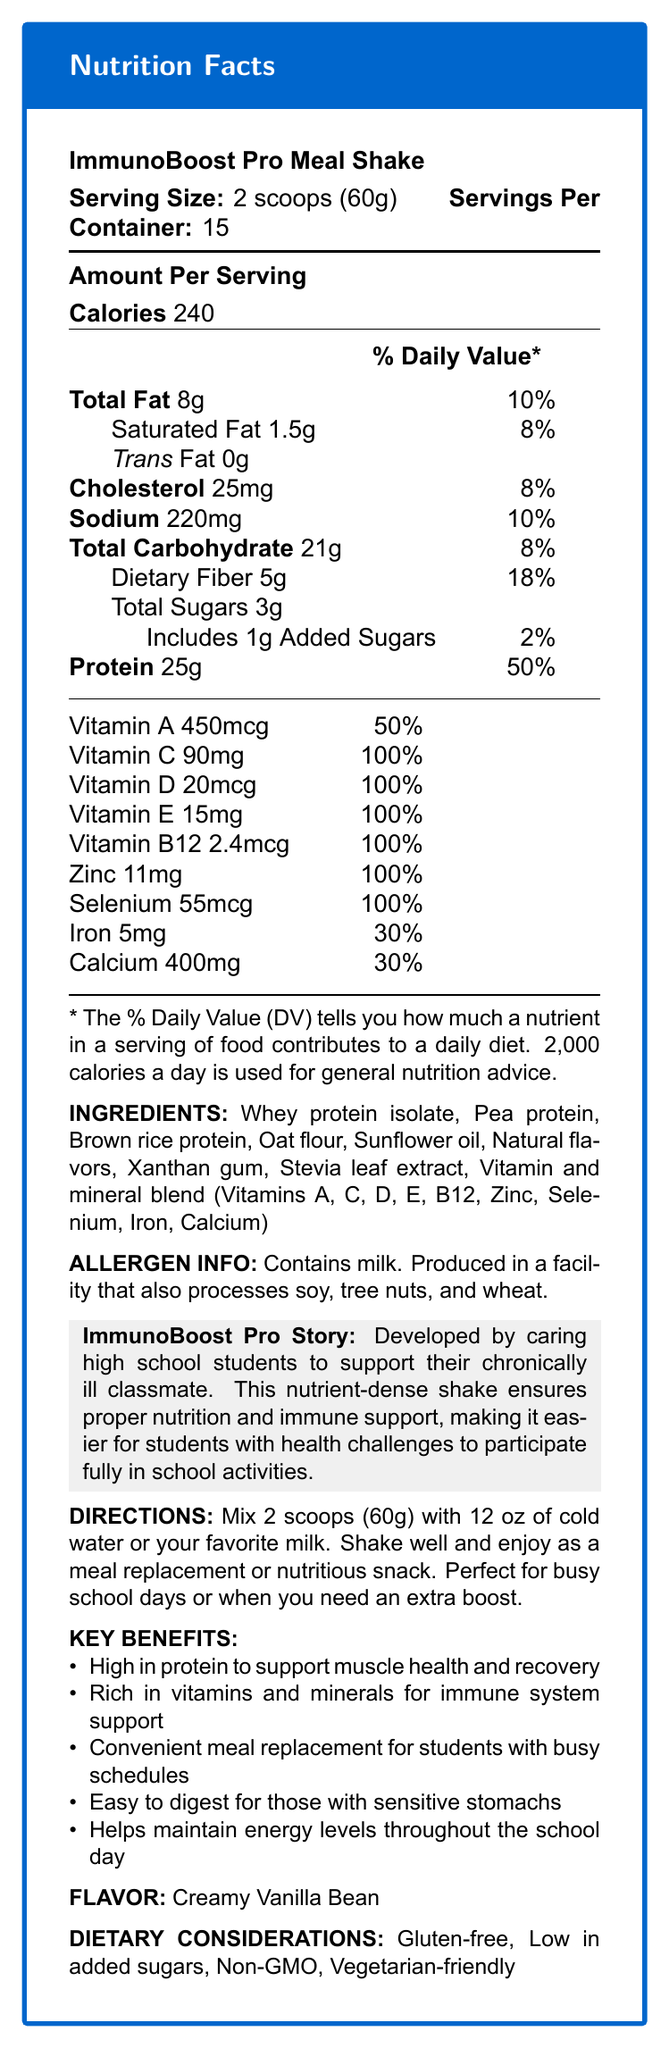What is the serving size for the ImmunoBoost Pro Meal Shake? The serving size is listed at the beginning of the document as "Serving Size: 2 scoops (60g)".
Answer: 2 scoops (60g) How many servings are there per container? The document specifies "Servings Per Container: 15".
Answer: 15 How many calories are there per serving of the shake? The "Amount Per Serving" section lists 240 calories.
Answer: 240 List three key benefits of the ImmunoBoost Pro Meal Shake. The key benefits section lists several benefits; these three are mentioned explicitly.
Answer: High in protein, Rich in vitamins and minerals for immune system support, Convenient meal replacement for busy schedules What is the amount of protein per serving? In the "Amount Per Serving" section, it mentions "Protein 25g".
Answer: 25g Does this product contain any allergens? The allergen information states "Contains milk. Produced in a facility that also processes soy, tree nuts, and wheat."
Answer: Yes What is the percentage daily value of vitamin C per serving? A. 50% B. 100% C. 25% D. 30% The document shows vitamin C has a daily value of 100%.
Answer: B. 100% Which vitamin is NOT included in the vitamin and mineral blend? A. Vitamin A B. Vitamin C C. Vitamin K D. Vitamin D The vitamin and mineral blend lists vitamins A, C, D, E, B12, zinc, selenium, iron, and calcium, but not vitamin K.
Answer: C. Vitamin K Is this meal replacement shake gluten-free? Under "Dietary Considerations," it states that the shake is gluten-free.
Answer: Yes Summarize the main purpose and benefits of the ImmunoBoost Pro Meal Shake. The document describes its development by caring students for a chronically ill classmate, highlighting its nutritional support and convenience.
Answer: The ImmunoBoost Pro Meal Shake is designed to support chronically ill students by providing a nutrient-dense, protein-rich meal replacement. It offers immune support through added vitamins and minerals, is easy to digest, and helps maintain energy levels throughout the school day. What is the natural flavoring agent used in this meal replacement shake? The ingredients list includes "Natural flavors" as one of the components.
Answer: Natural flavors What additional information would you need to determine if this product is suitable for someone with a peanut allergy? The document states it is produced in a facility that processes tree nuts but does not specify peanuts.
Answer: Not enough information When should you consume this meal replacement shake according to the directions? The directions mention these specific situations for consumption.
Answer: As a meal replacement or nutritious snack, perfect for busy school days or when you need an extra boost What flavor is the ImmunoBoost Pro Meal Shake? It is mentioned under "Flavor: Creamy Vanilla Bean".
Answer: Creamy Vanilla Bean How much fat is in each serving of the shake? A. 8g B. 1.5g C. 3g D. 0g The "Total Fat" is listed as 8g in the "Amount Per Serving" section.
Answer: A. 8g What is the role of the vitamins and minerals blend in the shake? One of the key benefits is "Rich in vitamins and minerals for immune system support".
Answer: To provide immune system support Can you determine the exact proportion of each protein source in the shake? The ingredients list includes whey protein isolate, pea protein, and brown rice protein but does not specify their proportions.
Answer: No, not enough information What is the daily value percentage for dietary fiber per serving? A. 30% B. 8% C. 10% D. 18% The "Dietary Fiber" daily value is listed as 18% in the nutritional information.
Answer: D. 18% How is the product personalized for chronically ill students? The brand story mentions this purpose explicitly, detailing support for health challenges in a school setting.
Answer: By ensuring proper nutrition and immune support, making it easier for them to participate fully in school activities 